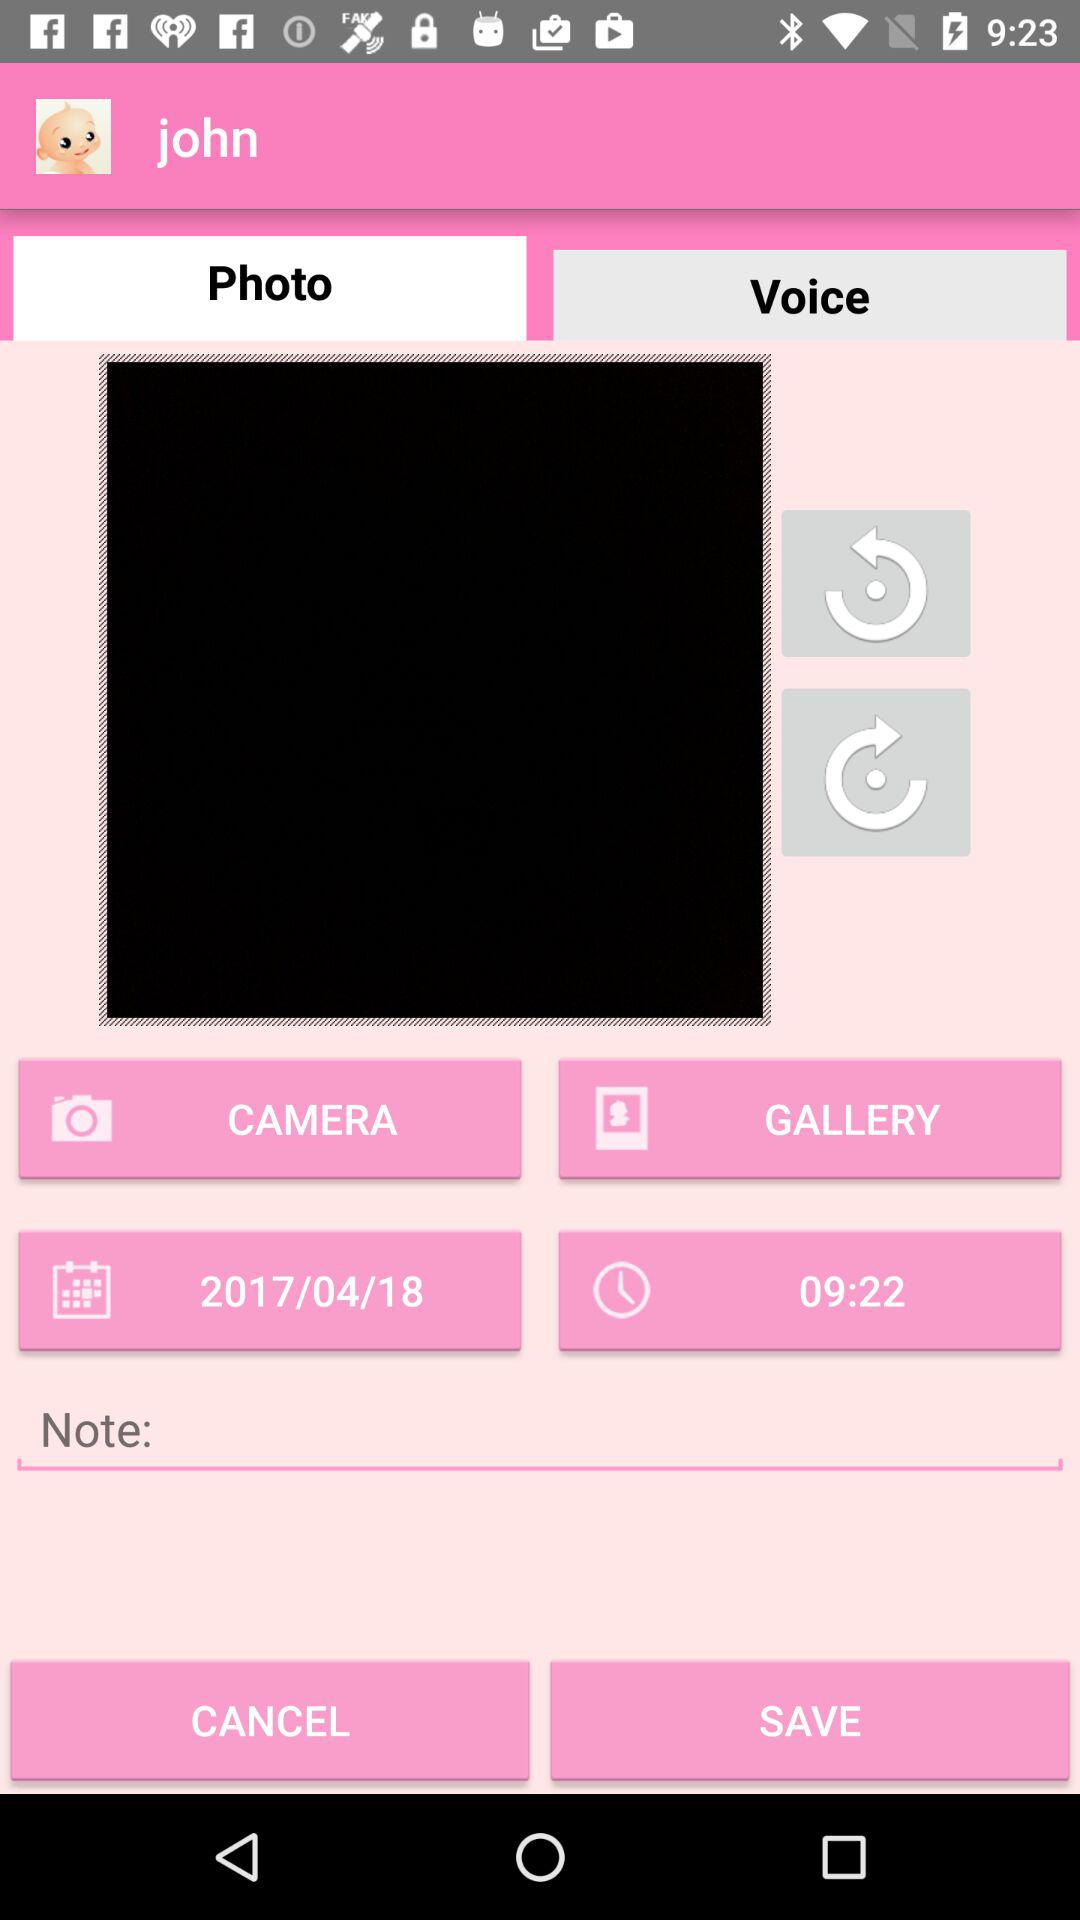What is the profile name? The profile name is John. 